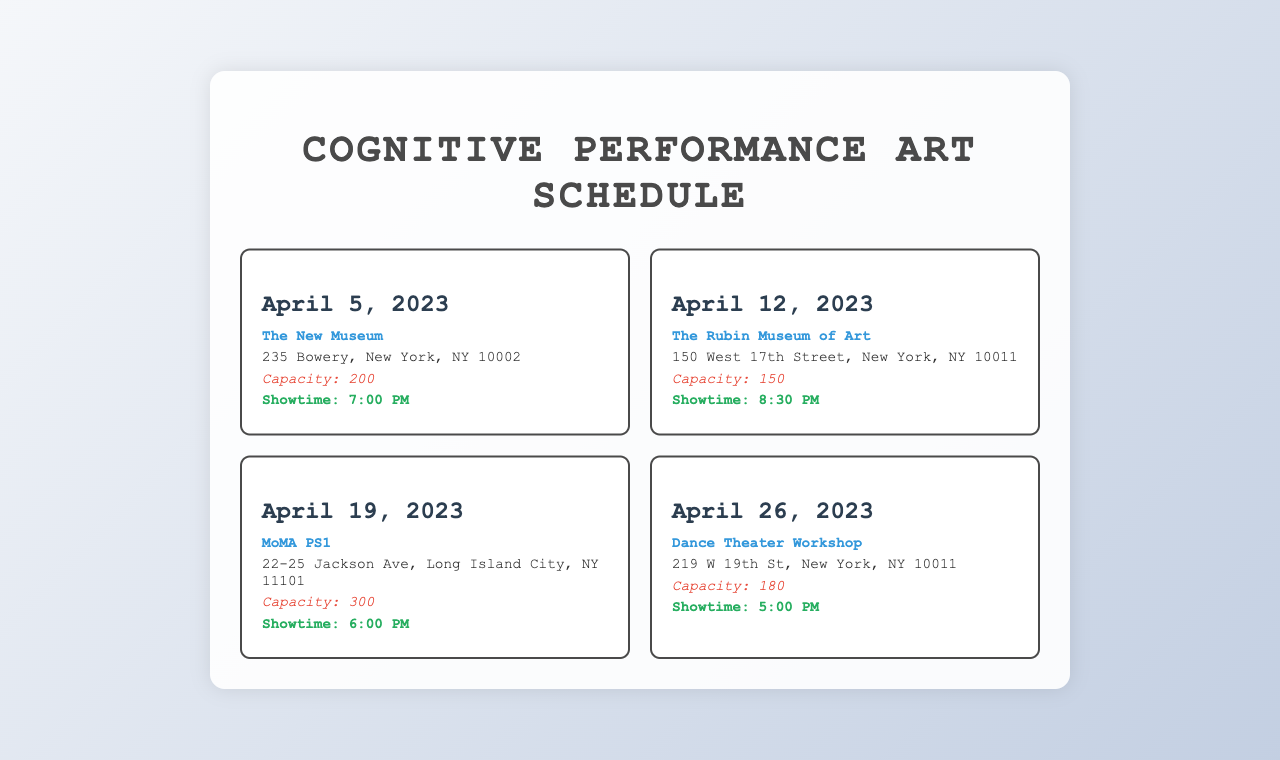What is the first event date? The documentation lists the first event date as April 5, 2023.
Answer: April 5, 2023 What is the name of the venue for the event on April 12, 2023? For April 12, 2023, the venue mentioned is The Rubin Museum of Art.
Answer: The Rubin Museum of Art What is the audience capacity for the event at MoMA PS1? The document specifies that MoMA PS1 has an audience capacity of 300.
Answer: 300 What time does the show on April 26, 2023, start? The showtime for April 26, 2023, is listed as 5:00 PM.
Answer: 5:00 PM Which venue has the lowest audience capacity? The venue with the lowest capacity listed is The Rubin Museum of Art, with a capacity of 150.
Answer: The Rubin Museum of Art How many total events are scheduled for April 2023? The document outlines a total of four events during April 2023.
Answer: 4 What is the address of The New Museum? The address listed for The New Museum is 235 Bowery, New York, NY 10002.
Answer: 235 Bowery, New York, NY 10002 Which event occurs last in April 2023? The last event in April 2023 is on April 26, 2023.
Answer: April 26, 2023 What is the capacity at Dance Theater Workshop? The capacity for the event at Dance Theater Workshop is noted as 180.
Answer: 180 